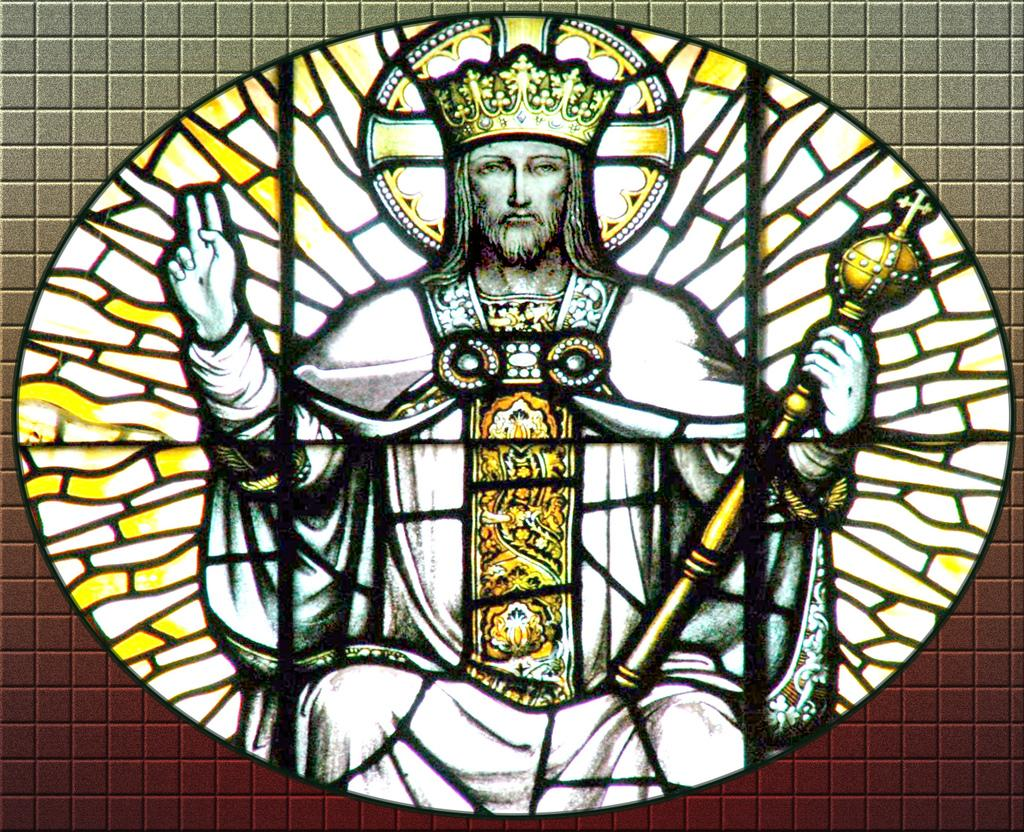What is the main subject of the image? There is a painting in the image. What is the person in the painting doing? The painting depicts a person sitting. What is the person holding in their hand? The person is holding something in their hand. What can be seen on the person's head in the painting? The person is wearing a crown. What type of cart is visible in the painting? There is no cart present in the painting; it depicts a person sitting and holding something in their hand. 